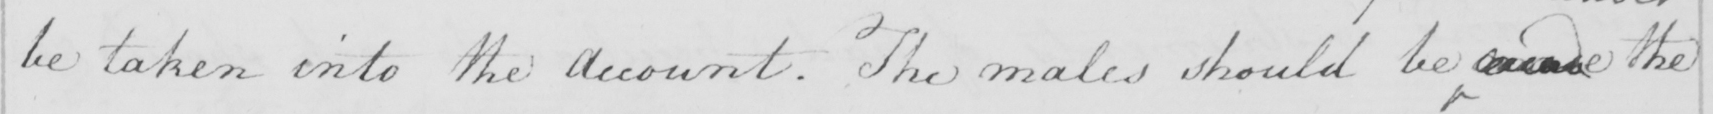Please transcribe the handwritten text in this image. be taken into the account . The males should be   <gap/>   the 